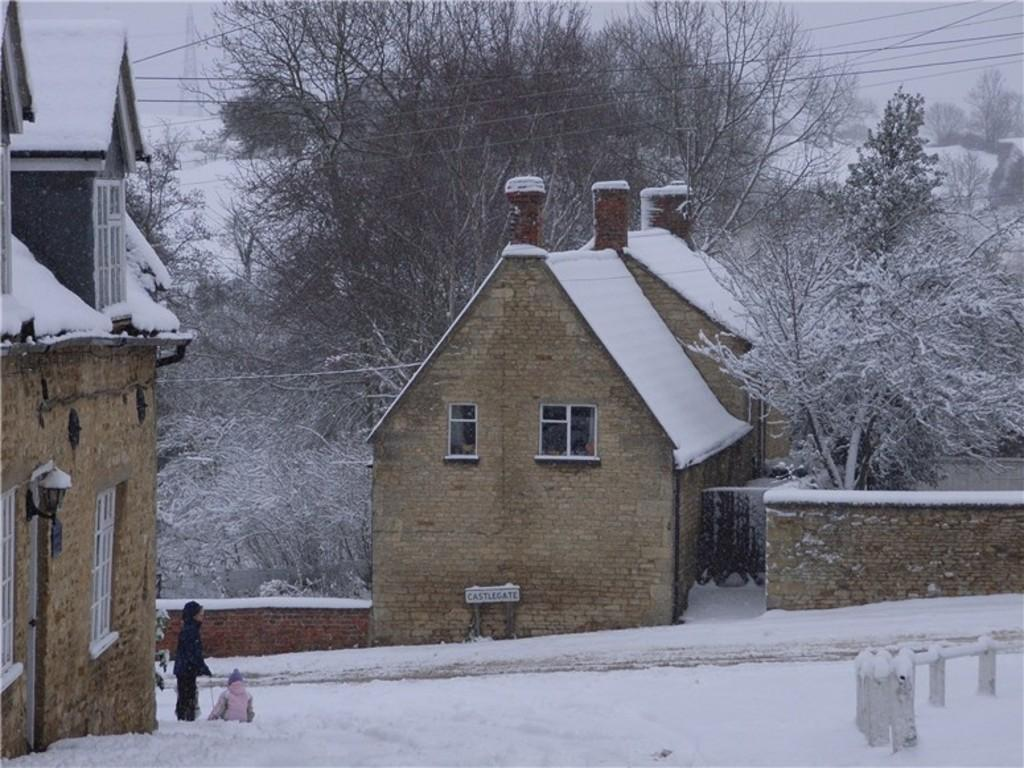How many people are in the image? There are two persons in the image. What is the surface they are standing on? The persons are on the snow. What can be seen in the background of the image? There are houses and trees in the background of the image. What colors are the houses? The houses are in brown and cream colors. What is the color of the sky in the image? The sky is white in color. What type of yarn is being used by the persons in the image? There is no yarn present in the image; the persons are standing on snow. Can you see a quiver on either of the persons in the image? There is no quiver visible in the image; the persons are not holding any weapons or equipment. 